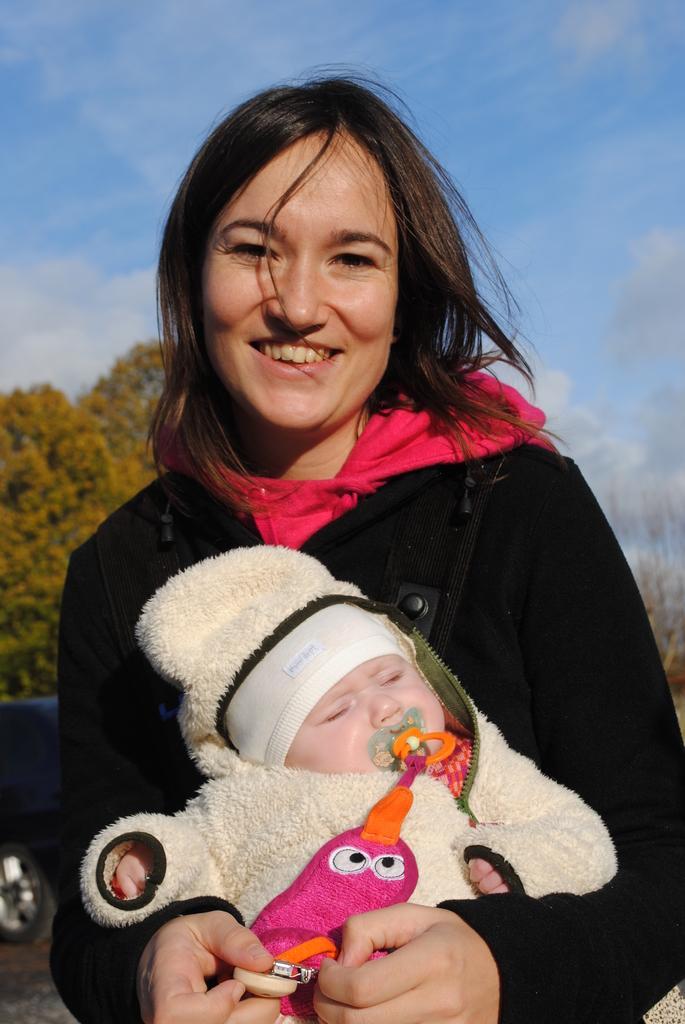In one or two sentences, can you explain what this image depicts? In the center of the image we can see one person is standing and she is smiling and she is holding one baby and some objects. And we can see they are in different costumes. In the background, we can see the sky, clouds, trees and a few other objects. 